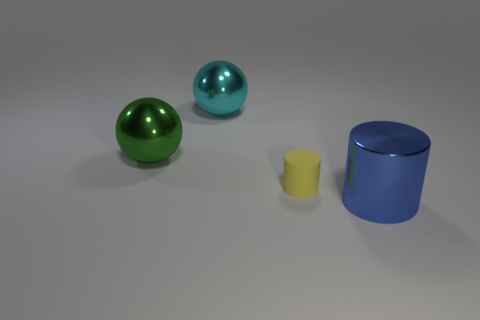Could you describe the atmosphere or mood conveyed by the colors in the image? The choice of colors in the image creates a calm and modern atmosphere. The cool cyan and green tones of the spheres set against the neutral grey background produce a serene and balanced visual effect. 